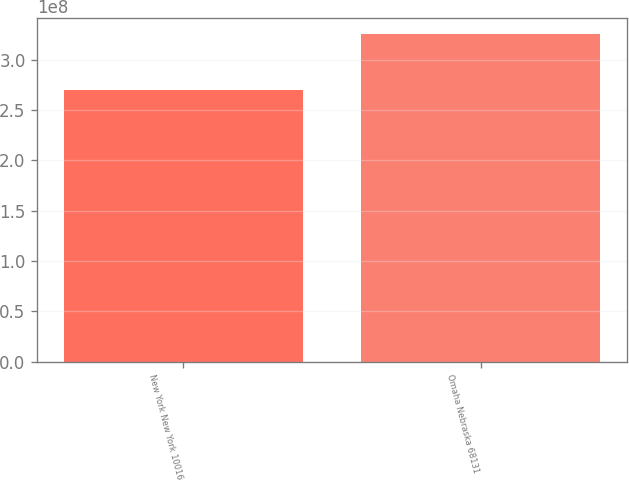Convert chart. <chart><loc_0><loc_0><loc_500><loc_500><bar_chart><fcel>New York New York 10016<fcel>Omaha Nebraska 68131<nl><fcel>2.70097e+08<fcel>3.25442e+08<nl></chart> 